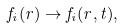<formula> <loc_0><loc_0><loc_500><loc_500>f _ { i } ( r ) \rightarrow f _ { i } ( r , t ) ,</formula> 